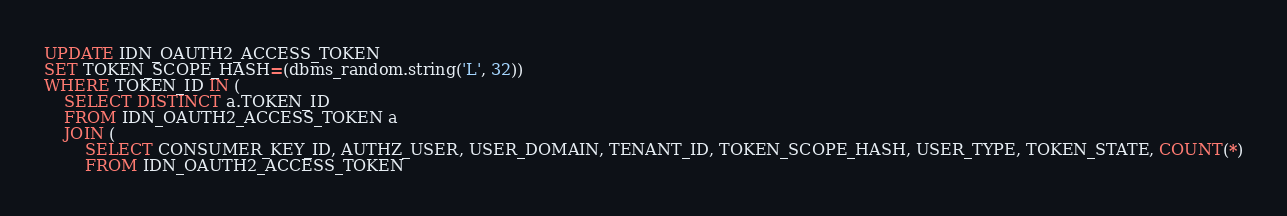<code> <loc_0><loc_0><loc_500><loc_500><_SQL_>UPDATE IDN_OAUTH2_ACCESS_TOKEN
SET TOKEN_SCOPE_HASH=(dbms_random.string('L', 32))
WHERE TOKEN_ID IN (
	SELECT DISTINCT a.TOKEN_ID
	FROM IDN_OAUTH2_ACCESS_TOKEN a
	JOIN (
		SELECT CONSUMER_KEY_ID, AUTHZ_USER, USER_DOMAIN, TENANT_ID, TOKEN_SCOPE_HASH, USER_TYPE, TOKEN_STATE, COUNT(*)
		FROM IDN_OAUTH2_ACCESS_TOKEN</code> 